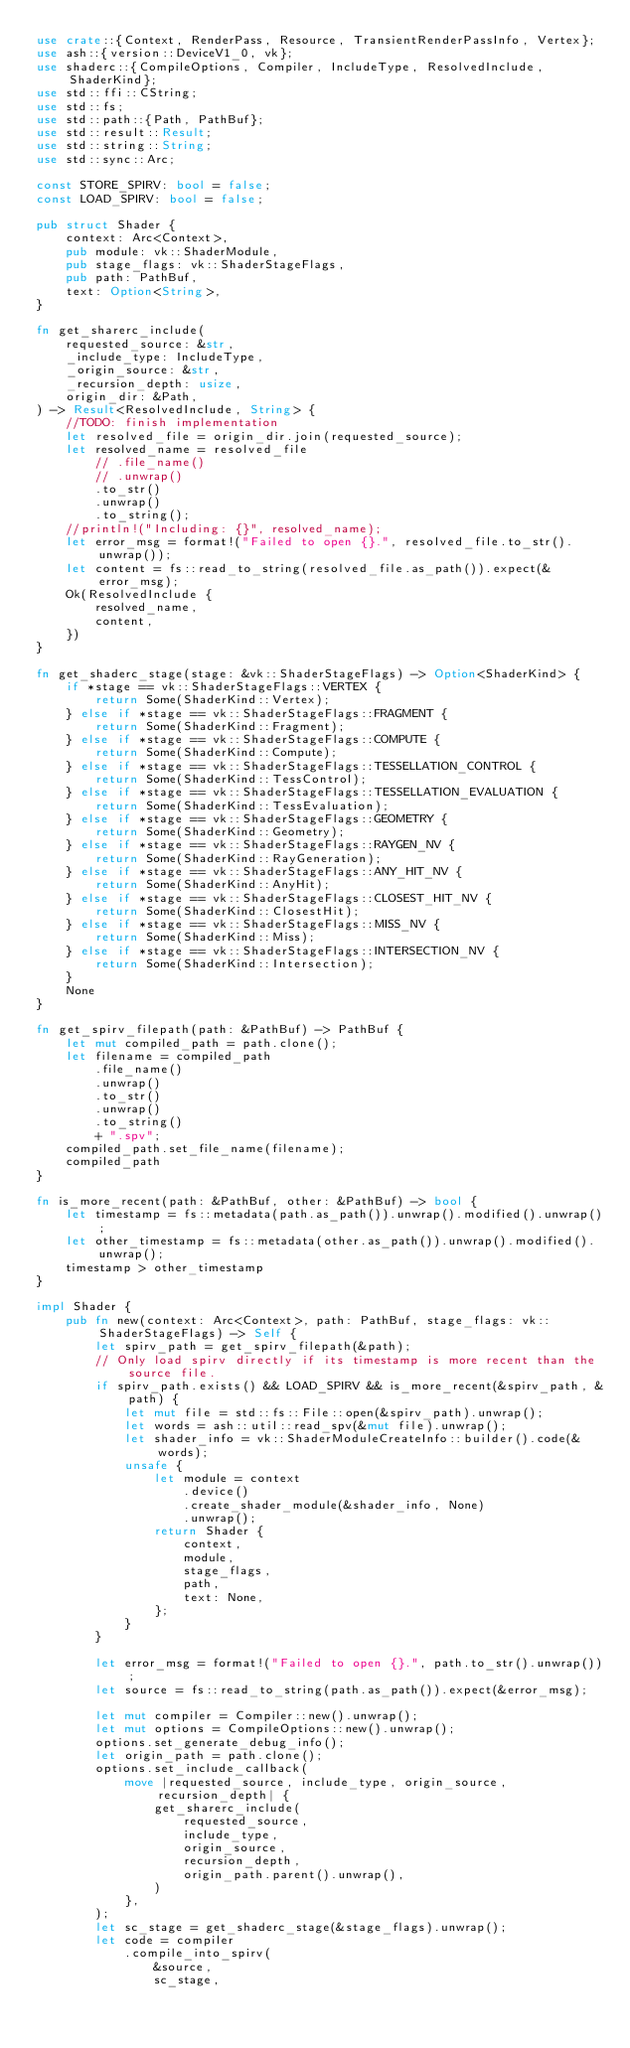Convert code to text. <code><loc_0><loc_0><loc_500><loc_500><_Rust_>use crate::{Context, RenderPass, Resource, TransientRenderPassInfo, Vertex};
use ash::{version::DeviceV1_0, vk};
use shaderc::{CompileOptions, Compiler, IncludeType, ResolvedInclude, ShaderKind};
use std::ffi::CString;
use std::fs;
use std::path::{Path, PathBuf};
use std::result::Result;
use std::string::String;
use std::sync::Arc;

const STORE_SPIRV: bool = false;
const LOAD_SPIRV: bool = false;

pub struct Shader {
    context: Arc<Context>,
    pub module: vk::ShaderModule,
    pub stage_flags: vk::ShaderStageFlags,
    pub path: PathBuf,
    text: Option<String>,
}

fn get_sharerc_include(
    requested_source: &str,
    _include_type: IncludeType,
    _origin_source: &str,
    _recursion_depth: usize,
    origin_dir: &Path,
) -> Result<ResolvedInclude, String> {
    //TODO: finish implementation
    let resolved_file = origin_dir.join(requested_source);
    let resolved_name = resolved_file
        // .file_name()
        // .unwrap()
        .to_str()
        .unwrap()
        .to_string();
    //println!("Including: {}", resolved_name);
    let error_msg = format!("Failed to open {}.", resolved_file.to_str().unwrap());
    let content = fs::read_to_string(resolved_file.as_path()).expect(&error_msg);
    Ok(ResolvedInclude {
        resolved_name,
        content,
    })
}

fn get_shaderc_stage(stage: &vk::ShaderStageFlags) -> Option<ShaderKind> {
    if *stage == vk::ShaderStageFlags::VERTEX {
        return Some(ShaderKind::Vertex);
    } else if *stage == vk::ShaderStageFlags::FRAGMENT {
        return Some(ShaderKind::Fragment);
    } else if *stage == vk::ShaderStageFlags::COMPUTE {
        return Some(ShaderKind::Compute);
    } else if *stage == vk::ShaderStageFlags::TESSELLATION_CONTROL {
        return Some(ShaderKind::TessControl);
    } else if *stage == vk::ShaderStageFlags::TESSELLATION_EVALUATION {
        return Some(ShaderKind::TessEvaluation);
    } else if *stage == vk::ShaderStageFlags::GEOMETRY {
        return Some(ShaderKind::Geometry);
    } else if *stage == vk::ShaderStageFlags::RAYGEN_NV {
        return Some(ShaderKind::RayGeneration);
    } else if *stage == vk::ShaderStageFlags::ANY_HIT_NV {
        return Some(ShaderKind::AnyHit);
    } else if *stage == vk::ShaderStageFlags::CLOSEST_HIT_NV {
        return Some(ShaderKind::ClosestHit);
    } else if *stage == vk::ShaderStageFlags::MISS_NV {
        return Some(ShaderKind::Miss);
    } else if *stage == vk::ShaderStageFlags::INTERSECTION_NV {
        return Some(ShaderKind::Intersection);
    }
    None
}

fn get_spirv_filepath(path: &PathBuf) -> PathBuf {
    let mut compiled_path = path.clone();
    let filename = compiled_path
        .file_name()
        .unwrap()
        .to_str()
        .unwrap()
        .to_string()
        + ".spv";
    compiled_path.set_file_name(filename);
    compiled_path
}

fn is_more_recent(path: &PathBuf, other: &PathBuf) -> bool {
    let timestamp = fs::metadata(path.as_path()).unwrap().modified().unwrap();
    let other_timestamp = fs::metadata(other.as_path()).unwrap().modified().unwrap();
    timestamp > other_timestamp
}

impl Shader {
    pub fn new(context: Arc<Context>, path: PathBuf, stage_flags: vk::ShaderStageFlags) -> Self {
        let spirv_path = get_spirv_filepath(&path);
        // Only load spirv directly if its timestamp is more recent than the source file.
        if spirv_path.exists() && LOAD_SPIRV && is_more_recent(&spirv_path, &path) {
            let mut file = std::fs::File::open(&spirv_path).unwrap();
            let words = ash::util::read_spv(&mut file).unwrap();
            let shader_info = vk::ShaderModuleCreateInfo::builder().code(&words);
            unsafe {
                let module = context
                    .device()
                    .create_shader_module(&shader_info, None)
                    .unwrap();
                return Shader {
                    context,
                    module,
                    stage_flags,
                    path,
                    text: None,
                };
            }
        }

        let error_msg = format!("Failed to open {}.", path.to_str().unwrap());
        let source = fs::read_to_string(path.as_path()).expect(&error_msg);

        let mut compiler = Compiler::new().unwrap();
        let mut options = CompileOptions::new().unwrap();
        options.set_generate_debug_info();
        let origin_path = path.clone();
        options.set_include_callback(
            move |requested_source, include_type, origin_source, recursion_depth| {
                get_sharerc_include(
                    requested_source,
                    include_type,
                    origin_source,
                    recursion_depth,
                    origin_path.parent().unwrap(),
                )
            },
        );
        let sc_stage = get_shaderc_stage(&stage_flags).unwrap();
        let code = compiler
            .compile_into_spirv(
                &source,
                sc_stage,</code> 